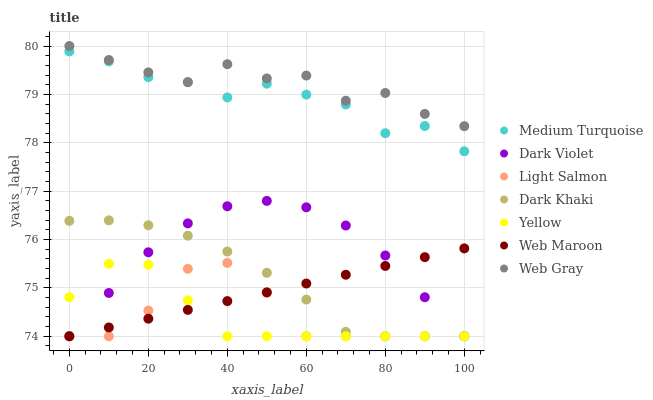Does Yellow have the minimum area under the curve?
Answer yes or no. Yes. Does Web Gray have the maximum area under the curve?
Answer yes or no. Yes. Does Web Maroon have the minimum area under the curve?
Answer yes or no. No. Does Web Maroon have the maximum area under the curve?
Answer yes or no. No. Is Web Maroon the smoothest?
Answer yes or no. Yes. Is Web Gray the roughest?
Answer yes or no. Yes. Is Web Gray the smoothest?
Answer yes or no. No. Is Web Maroon the roughest?
Answer yes or no. No. Does Light Salmon have the lowest value?
Answer yes or no. Yes. Does Web Gray have the lowest value?
Answer yes or no. No. Does Web Gray have the highest value?
Answer yes or no. Yes. Does Web Maroon have the highest value?
Answer yes or no. No. Is Web Maroon less than Web Gray?
Answer yes or no. Yes. Is Web Gray greater than Dark Violet?
Answer yes or no. Yes. Does Light Salmon intersect Yellow?
Answer yes or no. Yes. Is Light Salmon less than Yellow?
Answer yes or no. No. Is Light Salmon greater than Yellow?
Answer yes or no. No. Does Web Maroon intersect Web Gray?
Answer yes or no. No. 